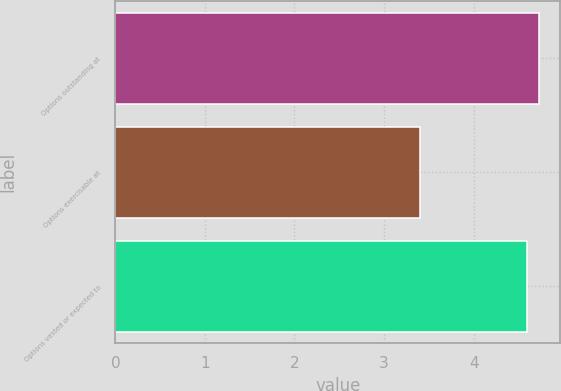Convert chart to OTSL. <chart><loc_0><loc_0><loc_500><loc_500><bar_chart><fcel>Options outstanding at<fcel>Options exercisable at<fcel>Options vested or expected to<nl><fcel>4.73<fcel>3.4<fcel>4.6<nl></chart> 